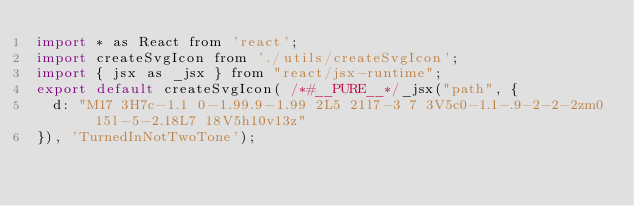Convert code to text. <code><loc_0><loc_0><loc_500><loc_500><_JavaScript_>import * as React from 'react';
import createSvgIcon from './utils/createSvgIcon';
import { jsx as _jsx } from "react/jsx-runtime";
export default createSvgIcon( /*#__PURE__*/_jsx("path", {
  d: "M17 3H7c-1.1 0-1.99.9-1.99 2L5 21l7-3 7 3V5c0-1.1-.9-2-2-2zm0 15l-5-2.18L7 18V5h10v13z"
}), 'TurnedInNotTwoTone');</code> 